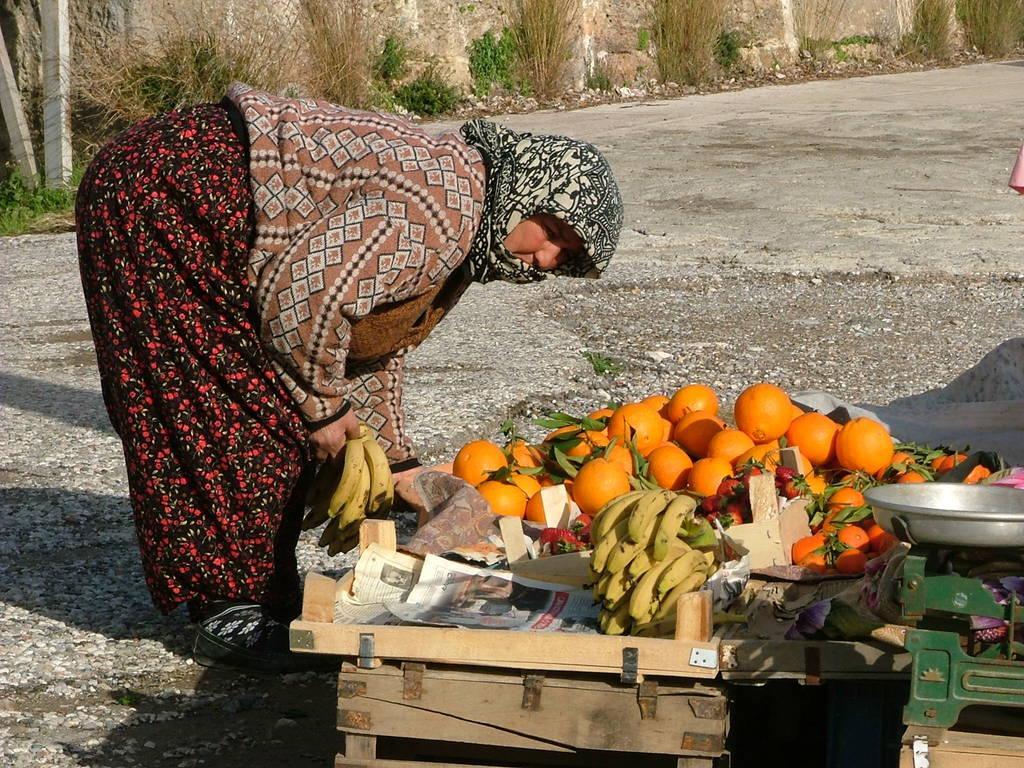Could you give a brief overview of what you see in this image? In this image there is a woman bending forward. In front of her there are wooden baskets. There are papers and fruits in the baskets. There are oranges and bananas. To the right there is a weighing machine on the basket. There is a bowl on the weighing machine. Behind her there is a road. In the background there are plants. 